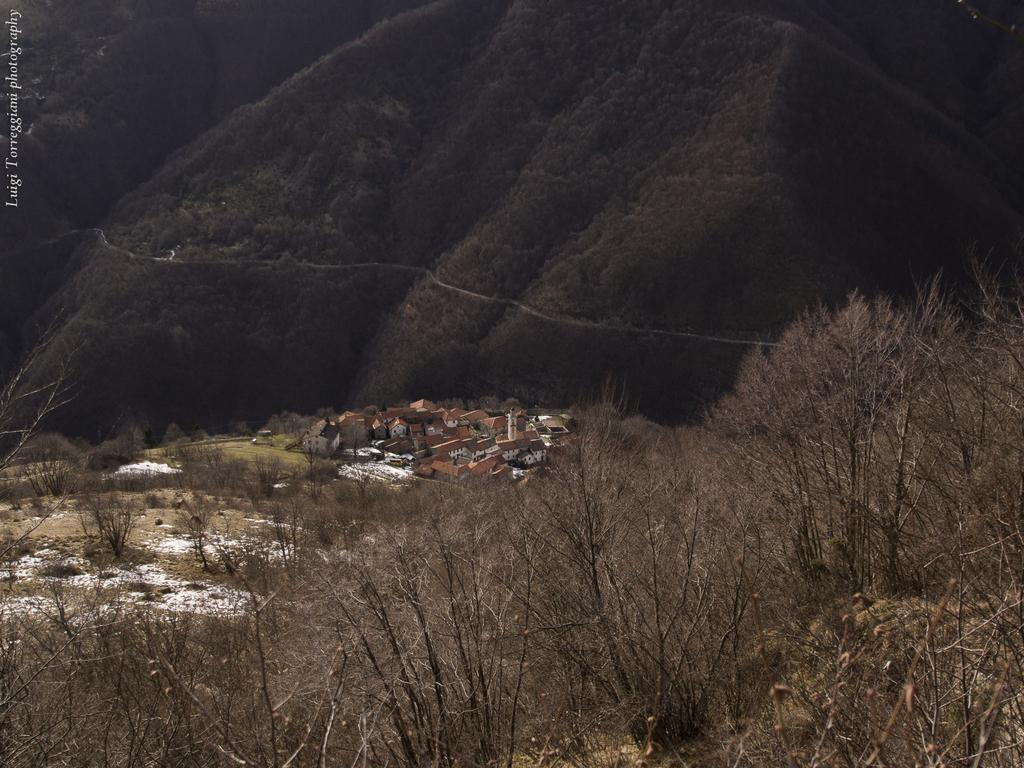What type of vegetation is visible in the front of the image? There are dry trees in the front of the image. What structures are located in the center of the image? There are houses in the center of the image. What type of geographical feature can be seen in the background of the image? There are mountains in the background of the image. What type of ground cover is present in the center of the image? There is grass in the center of the image. How many women are participating in the feast in the image? There is no feast or women present in the image. What is the aftermath of the event in the image? There is no event or aftermath depicted in the image; it shows dry trees, houses, grass, and mountains. 